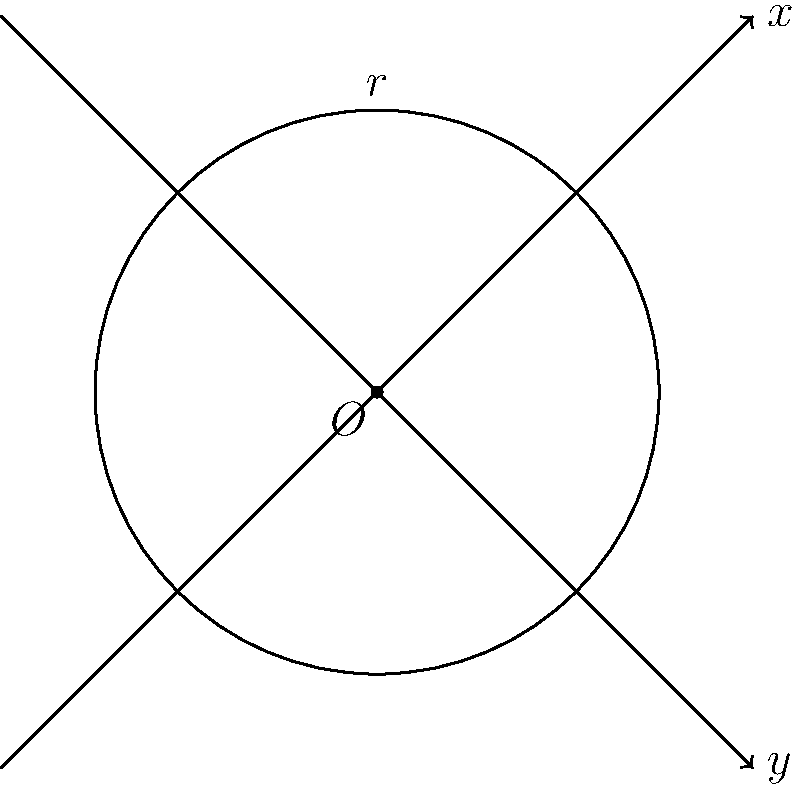During your research on Cold War nuclear weapons, you come across a document describing a nuclear test conducted in 1962. The document states that the blast was centered at coordinates (2, -1) and had a radius of 3 units (representing miles). What is the equation of the circle that represents the blast radius of this nuclear weapon? To find the equation of a circle given its center and radius, we can use the general form of a circle equation:

$$(x - h)^2 + (y - k)^2 = r^2$$

Where $(h, k)$ is the center of the circle and $r$ is the radius.

Given information:
- Center: (2, -1)
- Radius: 3 units

Let's substitute these values into the equation:

1) Center coordinates: $h = 2$ and $k = -1$
2) Radius: $r = 3$

Substituting into the general form:

$$(x - 2)^2 + (y - (-1))^2 = 3^2$$

Simplifying:

$$(x - 2)^2 + (y + 1)^2 = 9$$

This is the equation of the circle representing the blast radius of the nuclear weapon.
Answer: $(x - 2)^2 + (y + 1)^2 = 9$ 